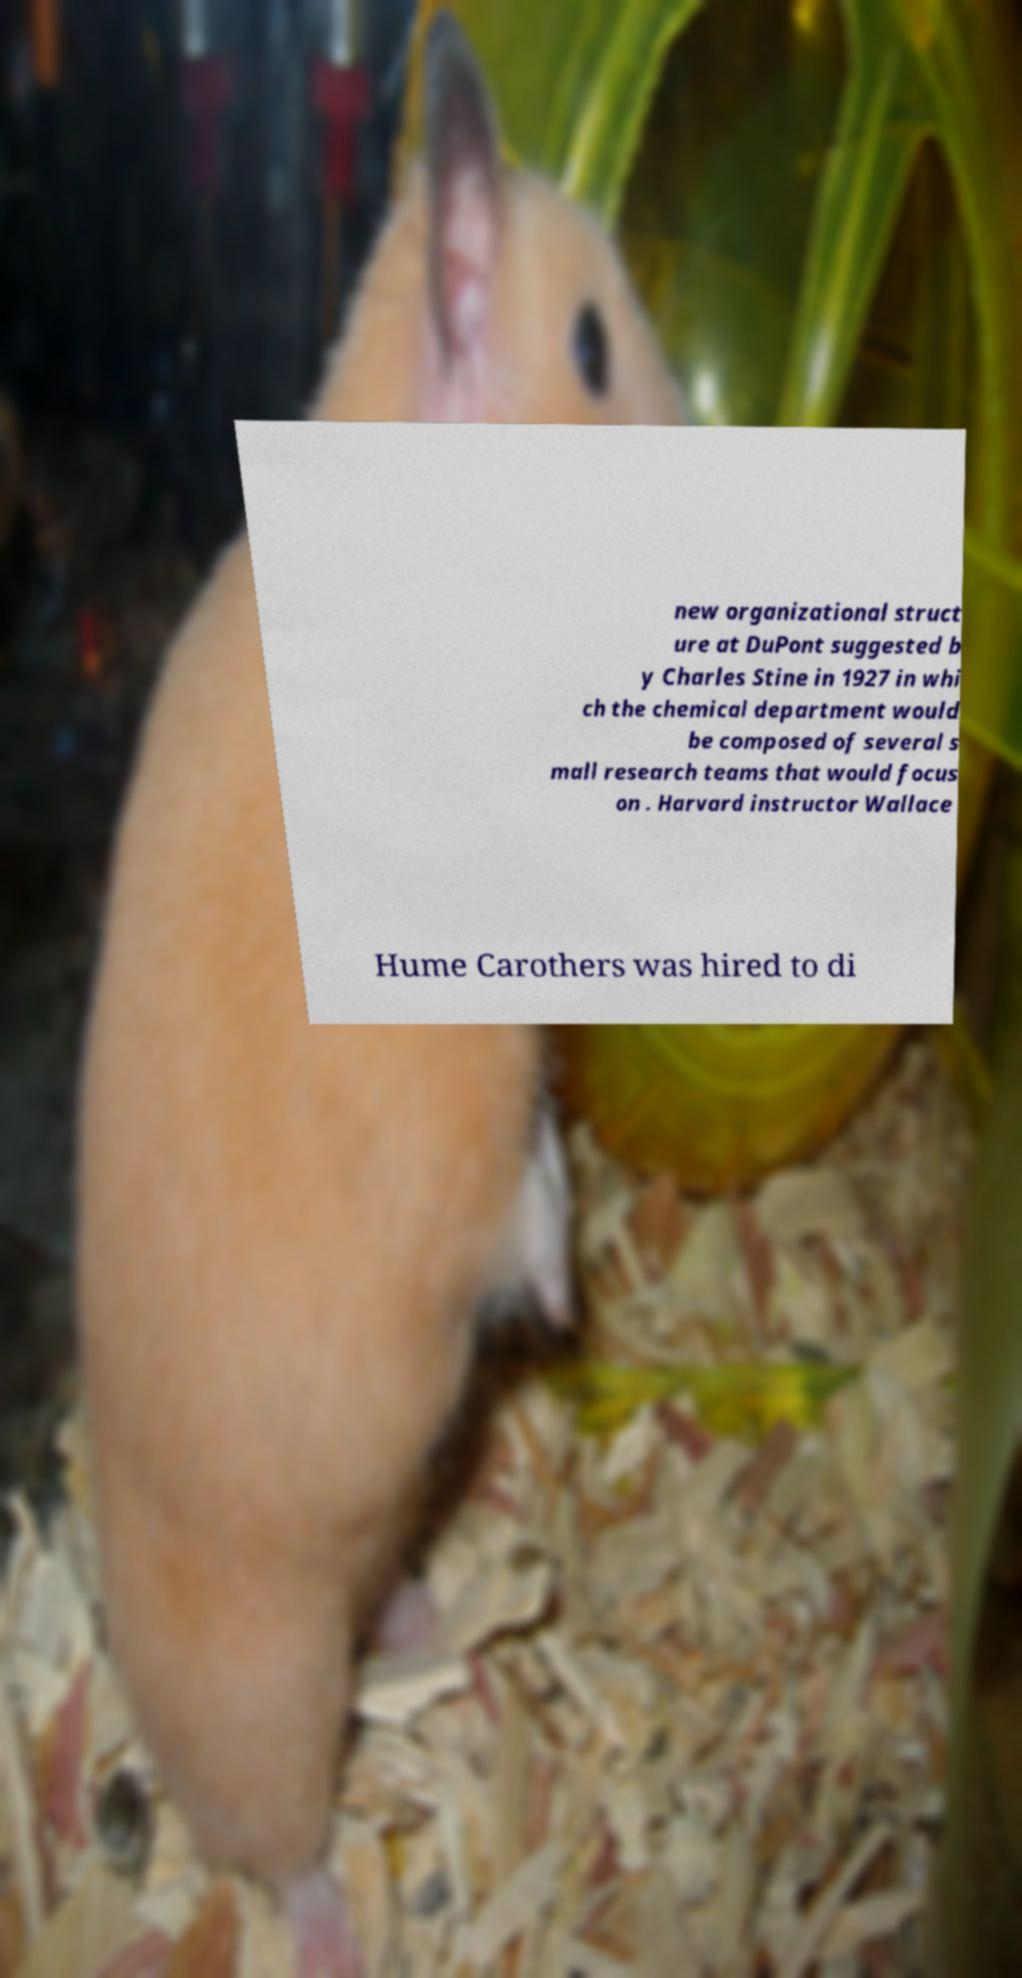There's text embedded in this image that I need extracted. Can you transcribe it verbatim? new organizational struct ure at DuPont suggested b y Charles Stine in 1927 in whi ch the chemical department would be composed of several s mall research teams that would focus on . Harvard instructor Wallace Hume Carothers was hired to di 